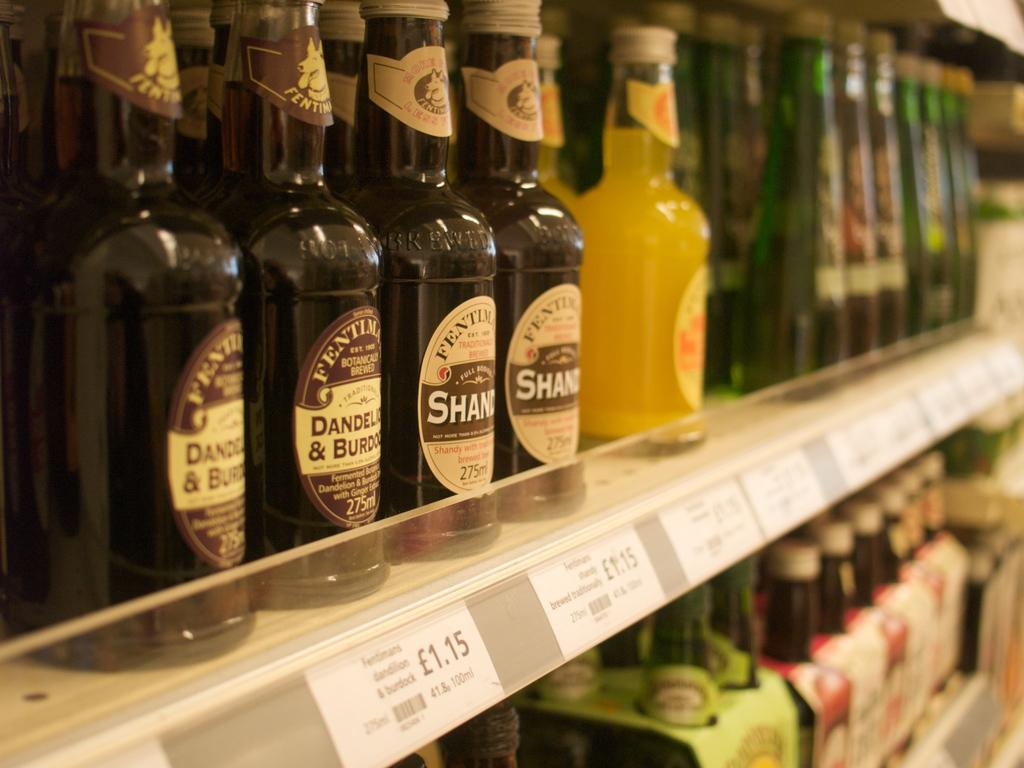<image>
Describe the image concisely. Alcohol on a shelf in a store which sells for $1.15. 